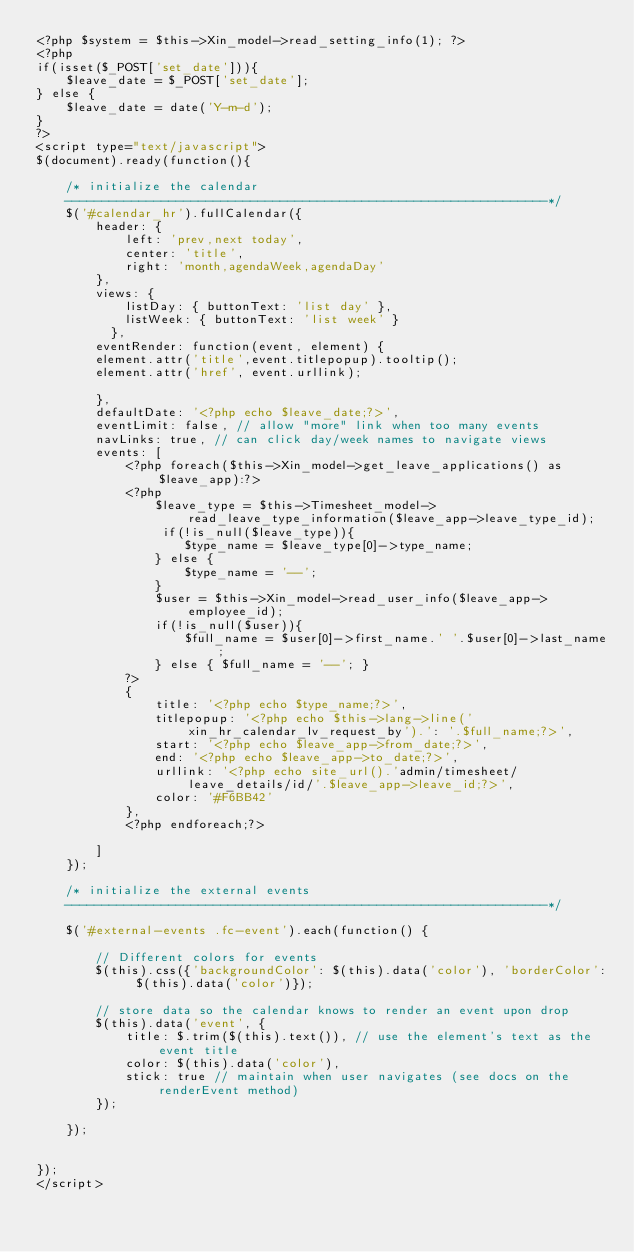<code> <loc_0><loc_0><loc_500><loc_500><_PHP_><?php $system = $this->Xin_model->read_setting_info(1); ?>
<?php
if(isset($_POST['set_date'])){
	$leave_date = $_POST['set_date'];
} else {
	$leave_date = date('Y-m-d');
}
?>
<script type="text/javascript">
$(document).ready(function(){
	
	/* initialize the calendar
	-----------------------------------------------------------------*/
	$('#calendar_hr').fullCalendar({
		header: {
			left: 'prev,next today',
			center: 'title',
			right: 'month,agendaWeek,agendaDay'
		},
		views: {
			listDay: { buttonText: 'list day' },
			listWeek: { buttonText: 'list week' }
		  },
		eventRender: function(event, element) {
		element.attr('title',event.titlepopup).tooltip();
		element.attr('href', event.urllink);
		
		},
		defaultDate: '<?php echo $leave_date;?>',
		eventLimit: false, // allow "more" link when too many events
		navLinks: true, // can click day/week names to navigate views
		events: [
			<?php foreach($this->Xin_model->get_leave_applications() as $leave_app):?>
			<?php
				$leave_type = $this->Timesheet_model->read_leave_type_information($leave_app->leave_type_id);
				 if(!is_null($leave_type)){
					$type_name = $leave_type[0]->type_name;
				} else {
					$type_name = '--';	
				}
				$user = $this->Xin_model->read_user_info($leave_app->employee_id);
				if(!is_null($user)){
					$full_name = $user[0]->first_name.' '.$user[0]->last_name;
				} else { $full_name = '--'; }
			?>
			{
				title: '<?php echo $type_name;?>',
				titlepopup: '<?php echo $this->lang->line('xin_hr_calendar_lv_request_by').': '.$full_name;?>',
				start: '<?php echo $leave_app->from_date;?>',
				end: '<?php echo $leave_app->to_date;?>',
				urllink: '<?php echo site_url().'admin/timesheet/leave_details/id/'.$leave_app->leave_id;?>',
				color: '#F6BB42'
			},
			<?php endforeach;?>
			
		]
	});
	
	/* initialize the external events
	-----------------------------------------------------------------*/

	$('#external-events .fc-event').each(function() {

		// Different colors for events
        $(this).css({'backgroundColor': $(this).data('color'), 'borderColor': $(this).data('color')});

		// store data so the calendar knows to render an event upon drop
		$(this).data('event', {
			title: $.trim($(this).text()), // use the element's text as the event title
			color: $(this).data('color'),
			stick: true // maintain when user navigates (see docs on the renderEvent method)
		});

	});


});
</script></code> 